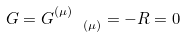<formula> <loc_0><loc_0><loc_500><loc_500>G = G ^ { ( \mu ) } _ { \quad ( \mu ) } = - R = 0</formula> 